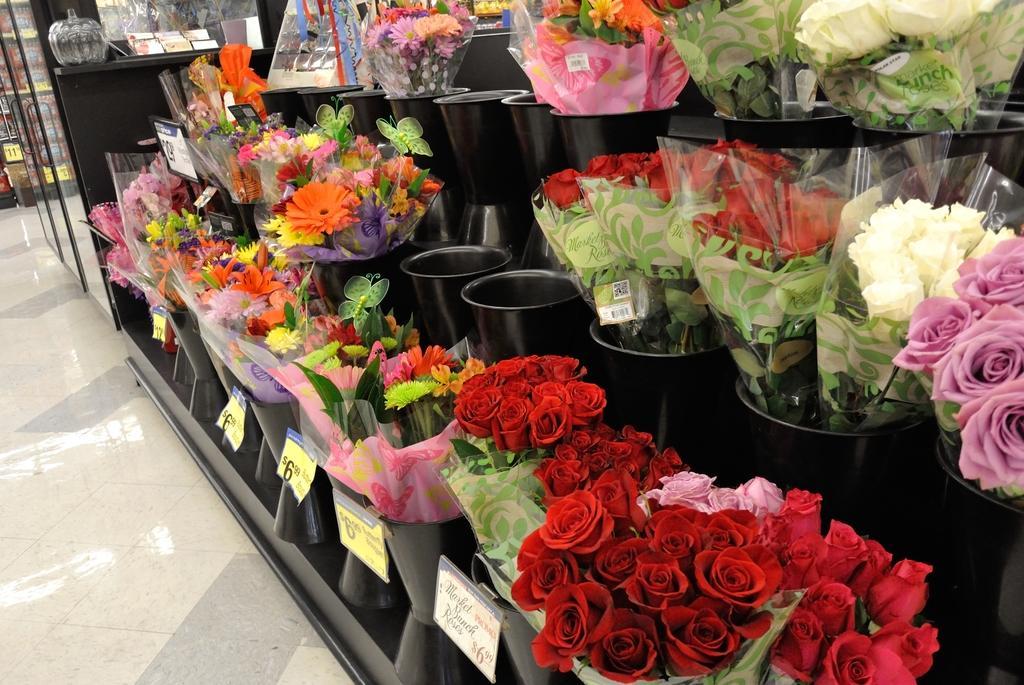Can you describe this image briefly? In this picture I can observe bouquets in the middle of the picture. I can observe different types of flowers in the middle of the picture. On the left side I can observe glass door. 